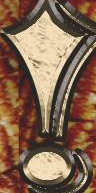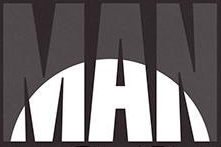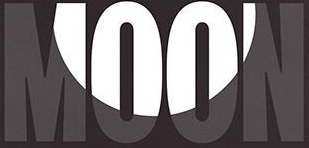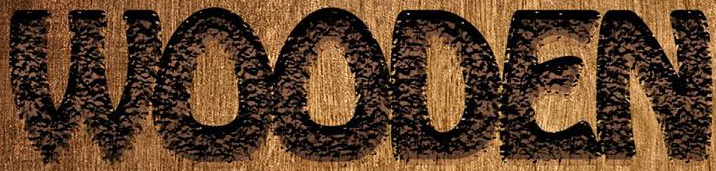Read the text from these images in sequence, separated by a semicolon. !; MAN; MOON; WOODEN 